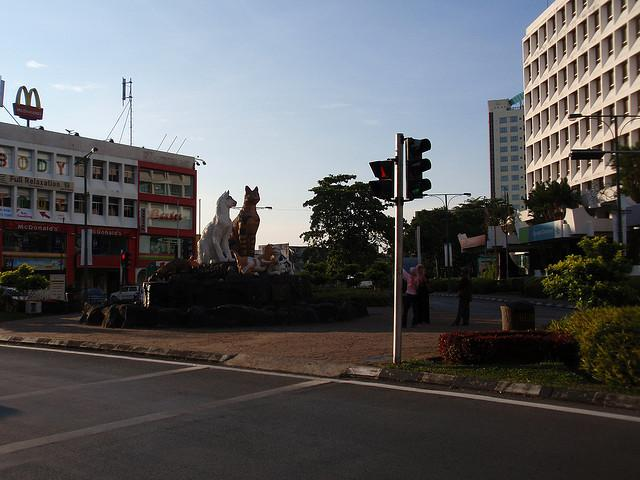What type of burger could be eaten here? Please explain your reasoning. big mac. The big mac burger is something to be bought at the mcdonalds. 